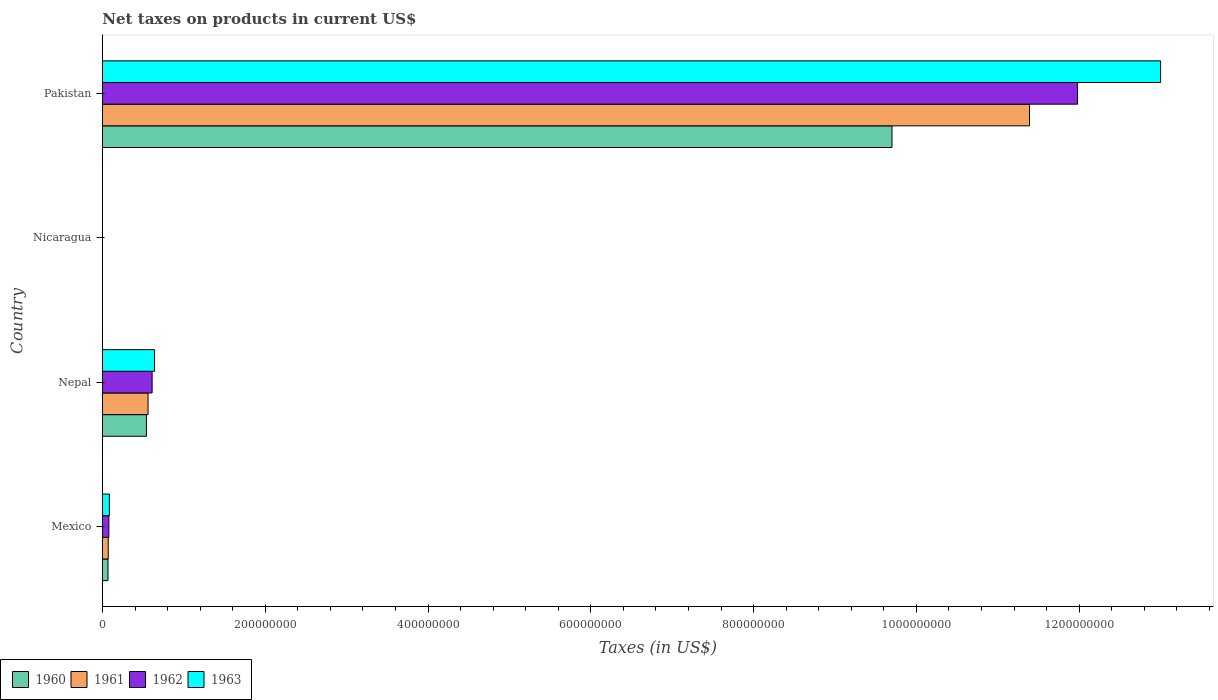How many different coloured bars are there?
Offer a very short reply. 4. Are the number of bars per tick equal to the number of legend labels?
Ensure brevity in your answer.  Yes. Are the number of bars on each tick of the Y-axis equal?
Ensure brevity in your answer.  Yes. How many bars are there on the 2nd tick from the top?
Give a very brief answer. 4. What is the label of the 1st group of bars from the top?
Offer a terse response. Pakistan. What is the net taxes on products in 1963 in Nepal?
Your answer should be compact. 6.40e+07. Across all countries, what is the maximum net taxes on products in 1960?
Provide a succinct answer. 9.70e+08. Across all countries, what is the minimum net taxes on products in 1960?
Make the answer very short. 0.03. In which country was the net taxes on products in 1960 maximum?
Ensure brevity in your answer.  Pakistan. In which country was the net taxes on products in 1961 minimum?
Offer a terse response. Nicaragua. What is the total net taxes on products in 1962 in the graph?
Your answer should be compact. 1.27e+09. What is the difference between the net taxes on products in 1963 in Mexico and that in Pakistan?
Keep it short and to the point. -1.29e+09. What is the difference between the net taxes on products in 1962 in Nepal and the net taxes on products in 1961 in Pakistan?
Provide a succinct answer. -1.08e+09. What is the average net taxes on products in 1960 per country?
Offer a very short reply. 2.58e+08. What is the difference between the net taxes on products in 1963 and net taxes on products in 1961 in Pakistan?
Give a very brief answer. 1.61e+08. In how many countries, is the net taxes on products in 1960 greater than 1160000000 US$?
Your response must be concise. 0. What is the ratio of the net taxes on products in 1961 in Nicaragua to that in Pakistan?
Offer a very short reply. 2.7346951921668807e-11. Is the net taxes on products in 1963 in Nepal less than that in Pakistan?
Ensure brevity in your answer.  Yes. What is the difference between the highest and the second highest net taxes on products in 1960?
Your answer should be very brief. 9.16e+08. What is the difference between the highest and the lowest net taxes on products in 1960?
Provide a short and direct response. 9.70e+08. In how many countries, is the net taxes on products in 1960 greater than the average net taxes on products in 1960 taken over all countries?
Your response must be concise. 1. Is it the case that in every country, the sum of the net taxes on products in 1962 and net taxes on products in 1963 is greater than the sum of net taxes on products in 1960 and net taxes on products in 1961?
Offer a terse response. No. Is it the case that in every country, the sum of the net taxes on products in 1962 and net taxes on products in 1960 is greater than the net taxes on products in 1961?
Offer a very short reply. Yes. Are all the bars in the graph horizontal?
Ensure brevity in your answer.  Yes. How many countries are there in the graph?
Provide a short and direct response. 4. What is the difference between two consecutive major ticks on the X-axis?
Your answer should be very brief. 2.00e+08. Does the graph contain any zero values?
Keep it short and to the point. No. Does the graph contain grids?
Your answer should be very brief. No. How many legend labels are there?
Give a very brief answer. 4. How are the legend labels stacked?
Ensure brevity in your answer.  Horizontal. What is the title of the graph?
Keep it short and to the point. Net taxes on products in current US$. Does "2011" appear as one of the legend labels in the graph?
Provide a succinct answer. No. What is the label or title of the X-axis?
Provide a short and direct response. Taxes (in US$). What is the Taxes (in US$) in 1960 in Mexico?
Provide a succinct answer. 6.81e+06. What is the Taxes (in US$) of 1961 in Mexico?
Keep it short and to the point. 7.08e+06. What is the Taxes (in US$) of 1962 in Mexico?
Provide a succinct answer. 7.85e+06. What is the Taxes (in US$) in 1963 in Mexico?
Offer a very short reply. 8.49e+06. What is the Taxes (in US$) in 1960 in Nepal?
Keep it short and to the point. 5.40e+07. What is the Taxes (in US$) in 1961 in Nepal?
Keep it short and to the point. 5.60e+07. What is the Taxes (in US$) of 1962 in Nepal?
Provide a short and direct response. 6.10e+07. What is the Taxes (in US$) of 1963 in Nepal?
Your answer should be compact. 6.40e+07. What is the Taxes (in US$) in 1960 in Nicaragua?
Your answer should be very brief. 0.03. What is the Taxes (in US$) of 1961 in Nicaragua?
Your response must be concise. 0.03. What is the Taxes (in US$) in 1962 in Nicaragua?
Make the answer very short. 0.04. What is the Taxes (in US$) in 1963 in Nicaragua?
Offer a very short reply. 0.04. What is the Taxes (in US$) in 1960 in Pakistan?
Provide a short and direct response. 9.70e+08. What is the Taxes (in US$) of 1961 in Pakistan?
Keep it short and to the point. 1.14e+09. What is the Taxes (in US$) in 1962 in Pakistan?
Your answer should be very brief. 1.20e+09. What is the Taxes (in US$) of 1963 in Pakistan?
Your response must be concise. 1.30e+09. Across all countries, what is the maximum Taxes (in US$) in 1960?
Your response must be concise. 9.70e+08. Across all countries, what is the maximum Taxes (in US$) in 1961?
Provide a succinct answer. 1.14e+09. Across all countries, what is the maximum Taxes (in US$) in 1962?
Ensure brevity in your answer.  1.20e+09. Across all countries, what is the maximum Taxes (in US$) of 1963?
Your answer should be very brief. 1.30e+09. Across all countries, what is the minimum Taxes (in US$) in 1960?
Give a very brief answer. 0.03. Across all countries, what is the minimum Taxes (in US$) in 1961?
Provide a succinct answer. 0.03. Across all countries, what is the minimum Taxes (in US$) of 1962?
Your answer should be very brief. 0.04. Across all countries, what is the minimum Taxes (in US$) of 1963?
Offer a terse response. 0.04. What is the total Taxes (in US$) in 1960 in the graph?
Provide a short and direct response. 1.03e+09. What is the total Taxes (in US$) of 1961 in the graph?
Your answer should be very brief. 1.20e+09. What is the total Taxes (in US$) in 1962 in the graph?
Provide a succinct answer. 1.27e+09. What is the total Taxes (in US$) of 1963 in the graph?
Ensure brevity in your answer.  1.37e+09. What is the difference between the Taxes (in US$) of 1960 in Mexico and that in Nepal?
Keep it short and to the point. -4.72e+07. What is the difference between the Taxes (in US$) of 1961 in Mexico and that in Nepal?
Keep it short and to the point. -4.89e+07. What is the difference between the Taxes (in US$) in 1962 in Mexico and that in Nepal?
Your response must be concise. -5.32e+07. What is the difference between the Taxes (in US$) in 1963 in Mexico and that in Nepal?
Offer a terse response. -5.55e+07. What is the difference between the Taxes (in US$) of 1960 in Mexico and that in Nicaragua?
Ensure brevity in your answer.  6.81e+06. What is the difference between the Taxes (in US$) of 1961 in Mexico and that in Nicaragua?
Provide a succinct answer. 7.08e+06. What is the difference between the Taxes (in US$) of 1962 in Mexico and that in Nicaragua?
Offer a terse response. 7.85e+06. What is the difference between the Taxes (in US$) in 1963 in Mexico and that in Nicaragua?
Make the answer very short. 8.49e+06. What is the difference between the Taxes (in US$) in 1960 in Mexico and that in Pakistan?
Ensure brevity in your answer.  -9.63e+08. What is the difference between the Taxes (in US$) of 1961 in Mexico and that in Pakistan?
Your answer should be very brief. -1.13e+09. What is the difference between the Taxes (in US$) of 1962 in Mexico and that in Pakistan?
Offer a terse response. -1.19e+09. What is the difference between the Taxes (in US$) of 1963 in Mexico and that in Pakistan?
Make the answer very short. -1.29e+09. What is the difference between the Taxes (in US$) of 1960 in Nepal and that in Nicaragua?
Ensure brevity in your answer.  5.40e+07. What is the difference between the Taxes (in US$) of 1961 in Nepal and that in Nicaragua?
Keep it short and to the point. 5.60e+07. What is the difference between the Taxes (in US$) in 1962 in Nepal and that in Nicaragua?
Make the answer very short. 6.10e+07. What is the difference between the Taxes (in US$) in 1963 in Nepal and that in Nicaragua?
Offer a terse response. 6.40e+07. What is the difference between the Taxes (in US$) in 1960 in Nepal and that in Pakistan?
Give a very brief answer. -9.16e+08. What is the difference between the Taxes (in US$) in 1961 in Nepal and that in Pakistan?
Ensure brevity in your answer.  -1.08e+09. What is the difference between the Taxes (in US$) of 1962 in Nepal and that in Pakistan?
Give a very brief answer. -1.14e+09. What is the difference between the Taxes (in US$) in 1963 in Nepal and that in Pakistan?
Provide a succinct answer. -1.24e+09. What is the difference between the Taxes (in US$) of 1960 in Nicaragua and that in Pakistan?
Your answer should be very brief. -9.70e+08. What is the difference between the Taxes (in US$) of 1961 in Nicaragua and that in Pakistan?
Provide a short and direct response. -1.14e+09. What is the difference between the Taxes (in US$) of 1962 in Nicaragua and that in Pakistan?
Give a very brief answer. -1.20e+09. What is the difference between the Taxes (in US$) in 1963 in Nicaragua and that in Pakistan?
Provide a succinct answer. -1.30e+09. What is the difference between the Taxes (in US$) in 1960 in Mexico and the Taxes (in US$) in 1961 in Nepal?
Offer a terse response. -4.92e+07. What is the difference between the Taxes (in US$) in 1960 in Mexico and the Taxes (in US$) in 1962 in Nepal?
Ensure brevity in your answer.  -5.42e+07. What is the difference between the Taxes (in US$) of 1960 in Mexico and the Taxes (in US$) of 1963 in Nepal?
Make the answer very short. -5.72e+07. What is the difference between the Taxes (in US$) of 1961 in Mexico and the Taxes (in US$) of 1962 in Nepal?
Your answer should be compact. -5.39e+07. What is the difference between the Taxes (in US$) of 1961 in Mexico and the Taxes (in US$) of 1963 in Nepal?
Offer a terse response. -5.69e+07. What is the difference between the Taxes (in US$) in 1962 in Mexico and the Taxes (in US$) in 1963 in Nepal?
Keep it short and to the point. -5.62e+07. What is the difference between the Taxes (in US$) of 1960 in Mexico and the Taxes (in US$) of 1961 in Nicaragua?
Your response must be concise. 6.81e+06. What is the difference between the Taxes (in US$) in 1960 in Mexico and the Taxes (in US$) in 1962 in Nicaragua?
Ensure brevity in your answer.  6.81e+06. What is the difference between the Taxes (in US$) of 1960 in Mexico and the Taxes (in US$) of 1963 in Nicaragua?
Offer a terse response. 6.81e+06. What is the difference between the Taxes (in US$) in 1961 in Mexico and the Taxes (in US$) in 1962 in Nicaragua?
Offer a very short reply. 7.08e+06. What is the difference between the Taxes (in US$) in 1961 in Mexico and the Taxes (in US$) in 1963 in Nicaragua?
Your response must be concise. 7.08e+06. What is the difference between the Taxes (in US$) of 1962 in Mexico and the Taxes (in US$) of 1963 in Nicaragua?
Your answer should be compact. 7.85e+06. What is the difference between the Taxes (in US$) in 1960 in Mexico and the Taxes (in US$) in 1961 in Pakistan?
Provide a succinct answer. -1.13e+09. What is the difference between the Taxes (in US$) in 1960 in Mexico and the Taxes (in US$) in 1962 in Pakistan?
Keep it short and to the point. -1.19e+09. What is the difference between the Taxes (in US$) of 1960 in Mexico and the Taxes (in US$) of 1963 in Pakistan?
Your response must be concise. -1.29e+09. What is the difference between the Taxes (in US$) of 1961 in Mexico and the Taxes (in US$) of 1962 in Pakistan?
Give a very brief answer. -1.19e+09. What is the difference between the Taxes (in US$) in 1961 in Mexico and the Taxes (in US$) in 1963 in Pakistan?
Provide a succinct answer. -1.29e+09. What is the difference between the Taxes (in US$) of 1962 in Mexico and the Taxes (in US$) of 1963 in Pakistan?
Your answer should be very brief. -1.29e+09. What is the difference between the Taxes (in US$) of 1960 in Nepal and the Taxes (in US$) of 1961 in Nicaragua?
Your response must be concise. 5.40e+07. What is the difference between the Taxes (in US$) of 1960 in Nepal and the Taxes (in US$) of 1962 in Nicaragua?
Ensure brevity in your answer.  5.40e+07. What is the difference between the Taxes (in US$) of 1960 in Nepal and the Taxes (in US$) of 1963 in Nicaragua?
Provide a succinct answer. 5.40e+07. What is the difference between the Taxes (in US$) in 1961 in Nepal and the Taxes (in US$) in 1962 in Nicaragua?
Provide a succinct answer. 5.60e+07. What is the difference between the Taxes (in US$) of 1961 in Nepal and the Taxes (in US$) of 1963 in Nicaragua?
Your answer should be very brief. 5.60e+07. What is the difference between the Taxes (in US$) of 1962 in Nepal and the Taxes (in US$) of 1963 in Nicaragua?
Make the answer very short. 6.10e+07. What is the difference between the Taxes (in US$) in 1960 in Nepal and the Taxes (in US$) in 1961 in Pakistan?
Offer a terse response. -1.08e+09. What is the difference between the Taxes (in US$) of 1960 in Nepal and the Taxes (in US$) of 1962 in Pakistan?
Keep it short and to the point. -1.14e+09. What is the difference between the Taxes (in US$) of 1960 in Nepal and the Taxes (in US$) of 1963 in Pakistan?
Your response must be concise. -1.25e+09. What is the difference between the Taxes (in US$) in 1961 in Nepal and the Taxes (in US$) in 1962 in Pakistan?
Your answer should be compact. -1.14e+09. What is the difference between the Taxes (in US$) of 1961 in Nepal and the Taxes (in US$) of 1963 in Pakistan?
Keep it short and to the point. -1.24e+09. What is the difference between the Taxes (in US$) of 1962 in Nepal and the Taxes (in US$) of 1963 in Pakistan?
Offer a terse response. -1.24e+09. What is the difference between the Taxes (in US$) of 1960 in Nicaragua and the Taxes (in US$) of 1961 in Pakistan?
Offer a very short reply. -1.14e+09. What is the difference between the Taxes (in US$) of 1960 in Nicaragua and the Taxes (in US$) of 1962 in Pakistan?
Make the answer very short. -1.20e+09. What is the difference between the Taxes (in US$) in 1960 in Nicaragua and the Taxes (in US$) in 1963 in Pakistan?
Keep it short and to the point. -1.30e+09. What is the difference between the Taxes (in US$) in 1961 in Nicaragua and the Taxes (in US$) in 1962 in Pakistan?
Your answer should be compact. -1.20e+09. What is the difference between the Taxes (in US$) of 1961 in Nicaragua and the Taxes (in US$) of 1963 in Pakistan?
Your answer should be compact. -1.30e+09. What is the difference between the Taxes (in US$) of 1962 in Nicaragua and the Taxes (in US$) of 1963 in Pakistan?
Your answer should be compact. -1.30e+09. What is the average Taxes (in US$) of 1960 per country?
Your answer should be very brief. 2.58e+08. What is the average Taxes (in US$) in 1961 per country?
Provide a succinct answer. 3.01e+08. What is the average Taxes (in US$) in 1962 per country?
Ensure brevity in your answer.  3.17e+08. What is the average Taxes (in US$) of 1963 per country?
Your response must be concise. 3.43e+08. What is the difference between the Taxes (in US$) of 1960 and Taxes (in US$) of 1961 in Mexico?
Give a very brief answer. -2.73e+05. What is the difference between the Taxes (in US$) of 1960 and Taxes (in US$) of 1962 in Mexico?
Offer a terse response. -1.04e+06. What is the difference between the Taxes (in US$) of 1960 and Taxes (in US$) of 1963 in Mexico?
Provide a succinct answer. -1.69e+06. What is the difference between the Taxes (in US$) of 1961 and Taxes (in US$) of 1962 in Mexico?
Offer a terse response. -7.69e+05. What is the difference between the Taxes (in US$) in 1961 and Taxes (in US$) in 1963 in Mexico?
Your response must be concise. -1.41e+06. What is the difference between the Taxes (in US$) in 1962 and Taxes (in US$) in 1963 in Mexico?
Make the answer very short. -6.43e+05. What is the difference between the Taxes (in US$) of 1960 and Taxes (in US$) of 1961 in Nepal?
Keep it short and to the point. -2.00e+06. What is the difference between the Taxes (in US$) in 1960 and Taxes (in US$) in 1962 in Nepal?
Give a very brief answer. -7.00e+06. What is the difference between the Taxes (in US$) in 1960 and Taxes (in US$) in 1963 in Nepal?
Provide a short and direct response. -1.00e+07. What is the difference between the Taxes (in US$) in 1961 and Taxes (in US$) in 1962 in Nepal?
Offer a terse response. -5.00e+06. What is the difference between the Taxes (in US$) in 1961 and Taxes (in US$) in 1963 in Nepal?
Keep it short and to the point. -8.00e+06. What is the difference between the Taxes (in US$) of 1962 and Taxes (in US$) of 1963 in Nepal?
Provide a succinct answer. -3.00e+06. What is the difference between the Taxes (in US$) of 1960 and Taxes (in US$) of 1961 in Nicaragua?
Provide a succinct answer. -0. What is the difference between the Taxes (in US$) in 1960 and Taxes (in US$) in 1962 in Nicaragua?
Provide a succinct answer. -0.01. What is the difference between the Taxes (in US$) in 1960 and Taxes (in US$) in 1963 in Nicaragua?
Give a very brief answer. -0.01. What is the difference between the Taxes (in US$) in 1961 and Taxes (in US$) in 1962 in Nicaragua?
Provide a succinct answer. -0. What is the difference between the Taxes (in US$) in 1961 and Taxes (in US$) in 1963 in Nicaragua?
Give a very brief answer. -0.01. What is the difference between the Taxes (in US$) of 1962 and Taxes (in US$) of 1963 in Nicaragua?
Make the answer very short. -0.01. What is the difference between the Taxes (in US$) in 1960 and Taxes (in US$) in 1961 in Pakistan?
Your answer should be compact. -1.69e+08. What is the difference between the Taxes (in US$) in 1960 and Taxes (in US$) in 1962 in Pakistan?
Your answer should be very brief. -2.28e+08. What is the difference between the Taxes (in US$) in 1960 and Taxes (in US$) in 1963 in Pakistan?
Make the answer very short. -3.30e+08. What is the difference between the Taxes (in US$) in 1961 and Taxes (in US$) in 1962 in Pakistan?
Make the answer very short. -5.90e+07. What is the difference between the Taxes (in US$) of 1961 and Taxes (in US$) of 1963 in Pakistan?
Your response must be concise. -1.61e+08. What is the difference between the Taxes (in US$) of 1962 and Taxes (in US$) of 1963 in Pakistan?
Your response must be concise. -1.02e+08. What is the ratio of the Taxes (in US$) in 1960 in Mexico to that in Nepal?
Provide a short and direct response. 0.13. What is the ratio of the Taxes (in US$) of 1961 in Mexico to that in Nepal?
Offer a very short reply. 0.13. What is the ratio of the Taxes (in US$) of 1962 in Mexico to that in Nepal?
Offer a very short reply. 0.13. What is the ratio of the Taxes (in US$) in 1963 in Mexico to that in Nepal?
Your answer should be very brief. 0.13. What is the ratio of the Taxes (in US$) in 1960 in Mexico to that in Nicaragua?
Your answer should be compact. 2.29e+08. What is the ratio of the Taxes (in US$) of 1961 in Mexico to that in Nicaragua?
Offer a very short reply. 2.27e+08. What is the ratio of the Taxes (in US$) of 1962 in Mexico to that in Nicaragua?
Your answer should be very brief. 2.22e+08. What is the ratio of the Taxes (in US$) of 1963 in Mexico to that in Nicaragua?
Your answer should be very brief. 2.04e+08. What is the ratio of the Taxes (in US$) in 1960 in Mexico to that in Pakistan?
Your answer should be compact. 0.01. What is the ratio of the Taxes (in US$) in 1961 in Mexico to that in Pakistan?
Your answer should be very brief. 0.01. What is the ratio of the Taxes (in US$) in 1962 in Mexico to that in Pakistan?
Make the answer very short. 0.01. What is the ratio of the Taxes (in US$) of 1963 in Mexico to that in Pakistan?
Ensure brevity in your answer.  0.01. What is the ratio of the Taxes (in US$) in 1960 in Nepal to that in Nicaragua?
Offer a terse response. 1.81e+09. What is the ratio of the Taxes (in US$) of 1961 in Nepal to that in Nicaragua?
Give a very brief answer. 1.80e+09. What is the ratio of the Taxes (in US$) in 1962 in Nepal to that in Nicaragua?
Your response must be concise. 1.73e+09. What is the ratio of the Taxes (in US$) in 1963 in Nepal to that in Nicaragua?
Ensure brevity in your answer.  1.54e+09. What is the ratio of the Taxes (in US$) in 1960 in Nepal to that in Pakistan?
Offer a very short reply. 0.06. What is the ratio of the Taxes (in US$) in 1961 in Nepal to that in Pakistan?
Your response must be concise. 0.05. What is the ratio of the Taxes (in US$) of 1962 in Nepal to that in Pakistan?
Offer a very short reply. 0.05. What is the ratio of the Taxes (in US$) of 1963 in Nepal to that in Pakistan?
Your answer should be compact. 0.05. What is the ratio of the Taxes (in US$) of 1963 in Nicaragua to that in Pakistan?
Your answer should be compact. 0. What is the difference between the highest and the second highest Taxes (in US$) in 1960?
Keep it short and to the point. 9.16e+08. What is the difference between the highest and the second highest Taxes (in US$) of 1961?
Your answer should be very brief. 1.08e+09. What is the difference between the highest and the second highest Taxes (in US$) in 1962?
Your answer should be very brief. 1.14e+09. What is the difference between the highest and the second highest Taxes (in US$) in 1963?
Offer a very short reply. 1.24e+09. What is the difference between the highest and the lowest Taxes (in US$) of 1960?
Your answer should be very brief. 9.70e+08. What is the difference between the highest and the lowest Taxes (in US$) of 1961?
Offer a very short reply. 1.14e+09. What is the difference between the highest and the lowest Taxes (in US$) in 1962?
Keep it short and to the point. 1.20e+09. What is the difference between the highest and the lowest Taxes (in US$) of 1963?
Offer a terse response. 1.30e+09. 